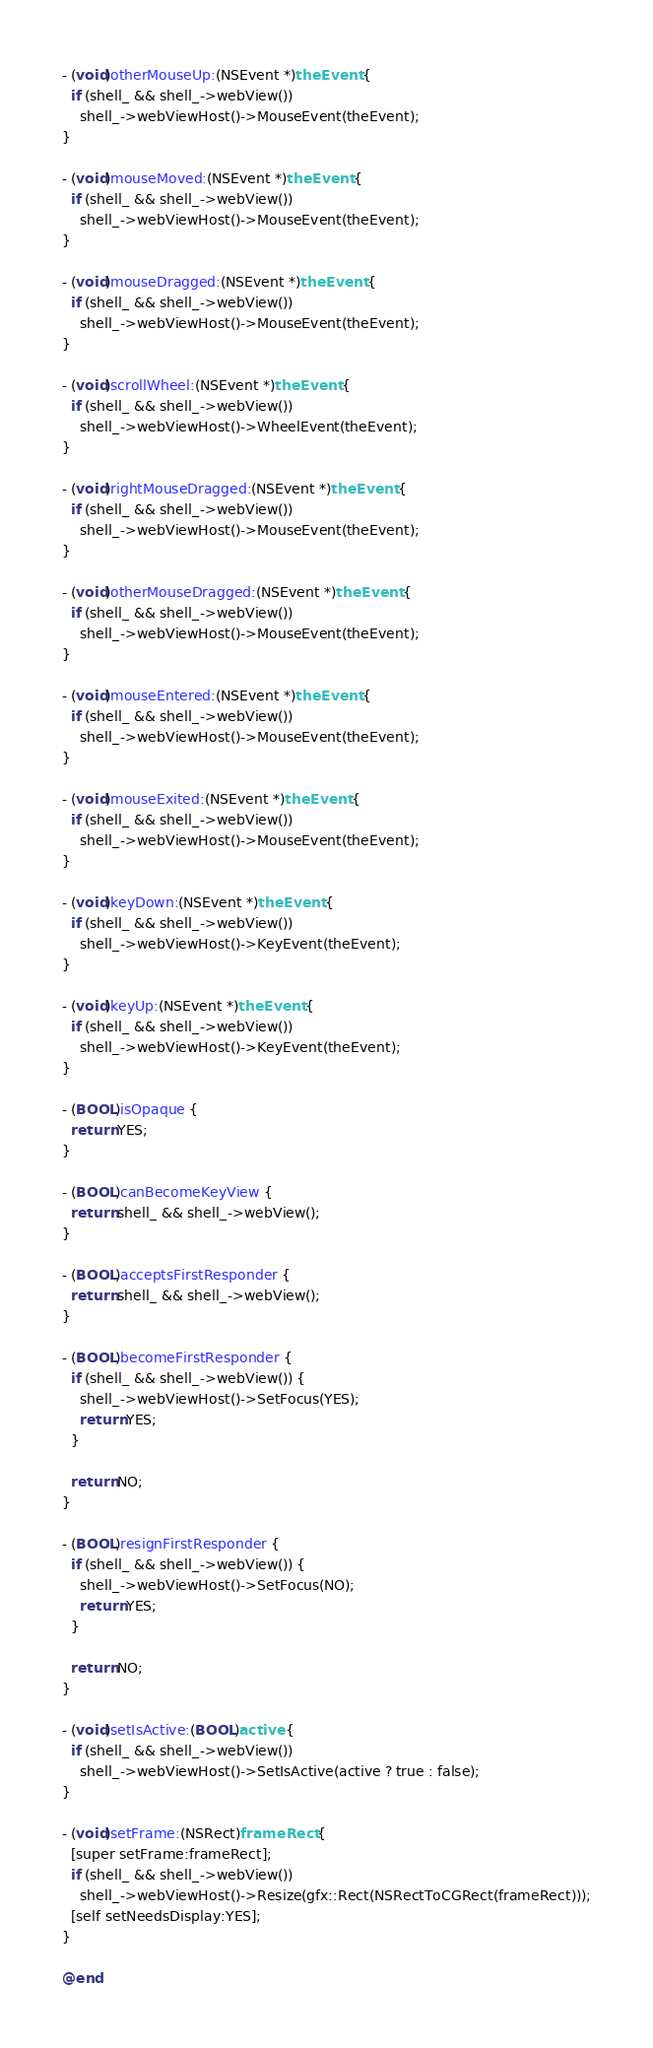Convert code to text. <code><loc_0><loc_0><loc_500><loc_500><_ObjectiveC_>
- (void)otherMouseUp:(NSEvent *)theEvent {
  if (shell_ && shell_->webView())
    shell_->webViewHost()->MouseEvent(theEvent);
}

- (void)mouseMoved:(NSEvent *)theEvent {
  if (shell_ && shell_->webView())
    shell_->webViewHost()->MouseEvent(theEvent);
}

- (void)mouseDragged:(NSEvent *)theEvent {
  if (shell_ && shell_->webView())
    shell_->webViewHost()->MouseEvent(theEvent);
}

- (void)scrollWheel:(NSEvent *)theEvent {
  if (shell_ && shell_->webView())
    shell_->webViewHost()->WheelEvent(theEvent);
}

- (void)rightMouseDragged:(NSEvent *)theEvent {
  if (shell_ && shell_->webView())
    shell_->webViewHost()->MouseEvent(theEvent);
}

- (void)otherMouseDragged:(NSEvent *)theEvent {
  if (shell_ && shell_->webView())
    shell_->webViewHost()->MouseEvent(theEvent);
}

- (void)mouseEntered:(NSEvent *)theEvent {
  if (shell_ && shell_->webView())
    shell_->webViewHost()->MouseEvent(theEvent);
}

- (void)mouseExited:(NSEvent *)theEvent {
  if (shell_ && shell_->webView())
    shell_->webViewHost()->MouseEvent(theEvent);
}

- (void)keyDown:(NSEvent *)theEvent {
  if (shell_ && shell_->webView())
    shell_->webViewHost()->KeyEvent(theEvent);
}

- (void)keyUp:(NSEvent *)theEvent {
  if (shell_ && shell_->webView())
    shell_->webViewHost()->KeyEvent(theEvent);
}

- (BOOL)isOpaque {
  return YES;
}

- (BOOL)canBecomeKeyView {
  return shell_ && shell_->webView();
}

- (BOOL)acceptsFirstResponder {
  return shell_ && shell_->webView();
}

- (BOOL)becomeFirstResponder {
  if (shell_ && shell_->webView()) {
    shell_->webViewHost()->SetFocus(YES);
    return YES;
  }

  return NO;
}

- (BOOL)resignFirstResponder {
  if (shell_ && shell_->webView()) {
    shell_->webViewHost()->SetFocus(NO);
    return YES;
  }

  return NO;
}

- (void)setIsActive:(BOOL)active {
  if (shell_ && shell_->webView())
    shell_->webViewHost()->SetIsActive(active ? true : false);
}

- (void)setFrame:(NSRect)frameRect {
  [super setFrame:frameRect];
  if (shell_ && shell_->webView())
    shell_->webViewHost()->Resize(gfx::Rect(NSRectToCGRect(frameRect)));
  [self setNeedsDisplay:YES];
}

@end
</code> 